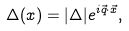<formula> <loc_0><loc_0><loc_500><loc_500>\Delta ( x ) = | \Delta | e ^ { i \vec { q } \cdot \vec { x } } ,</formula> 